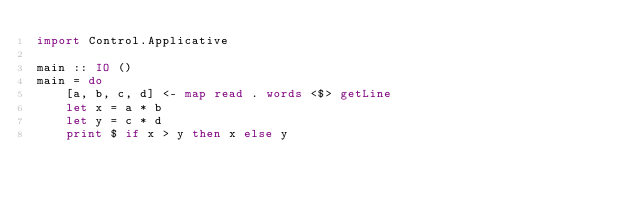<code> <loc_0><loc_0><loc_500><loc_500><_Haskell_>import Control.Applicative

main :: IO ()
main = do
    [a, b, c, d] <- map read . words <$> getLine
    let x = a * b
    let y = c * d
    print $ if x > y then x else y
</code> 